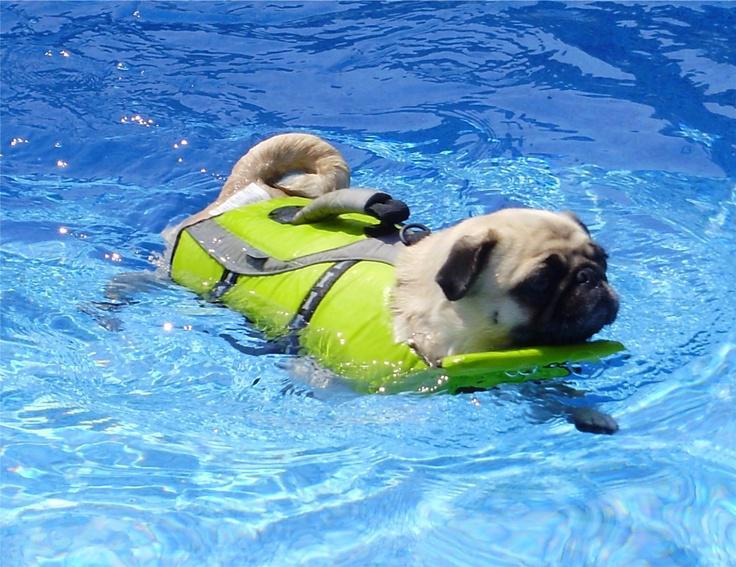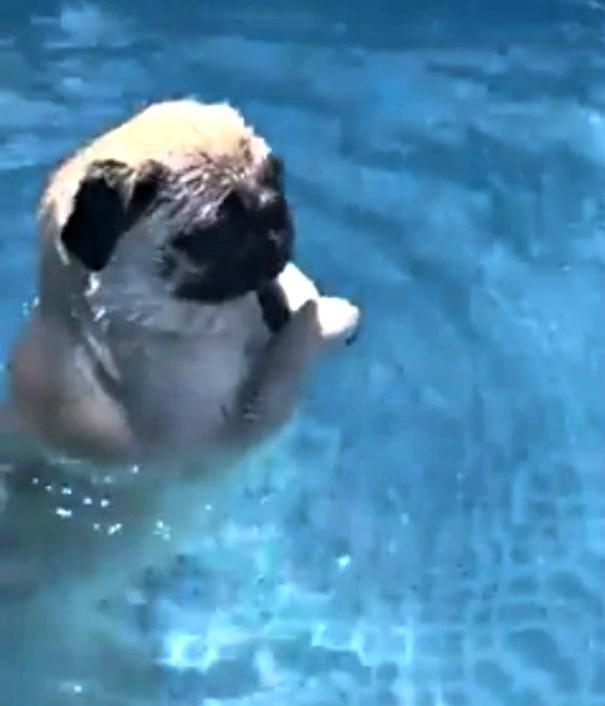The first image is the image on the left, the second image is the image on the right. Examine the images to the left and right. Is the description "In one image a pug dog is swimming in a pool while wearing a green life jacket." accurate? Answer yes or no. Yes. 